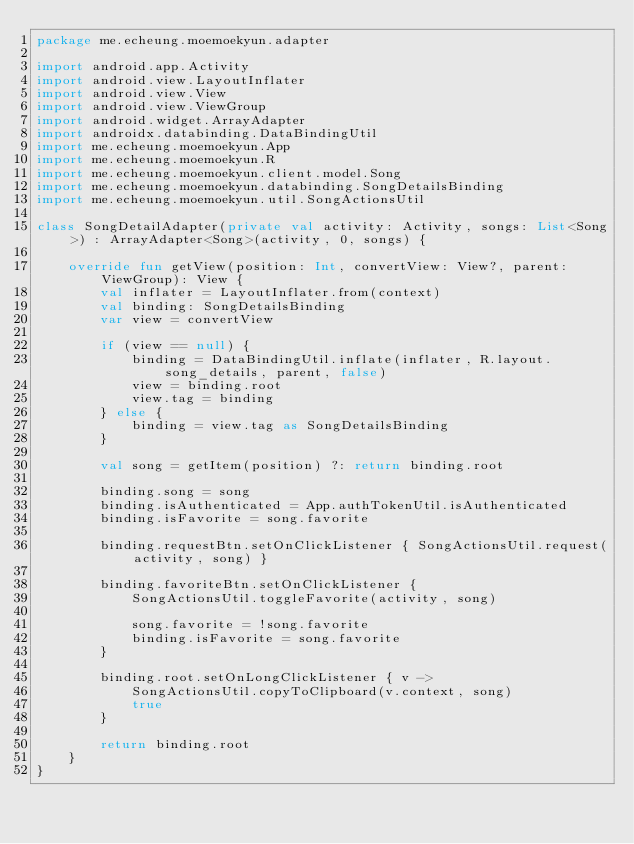<code> <loc_0><loc_0><loc_500><loc_500><_Kotlin_>package me.echeung.moemoekyun.adapter

import android.app.Activity
import android.view.LayoutInflater
import android.view.View
import android.view.ViewGroup
import android.widget.ArrayAdapter
import androidx.databinding.DataBindingUtil
import me.echeung.moemoekyun.App
import me.echeung.moemoekyun.R
import me.echeung.moemoekyun.client.model.Song
import me.echeung.moemoekyun.databinding.SongDetailsBinding
import me.echeung.moemoekyun.util.SongActionsUtil

class SongDetailAdapter(private val activity: Activity, songs: List<Song>) : ArrayAdapter<Song>(activity, 0, songs) {

    override fun getView(position: Int, convertView: View?, parent: ViewGroup): View {
        val inflater = LayoutInflater.from(context)
        val binding: SongDetailsBinding
        var view = convertView

        if (view == null) {
            binding = DataBindingUtil.inflate(inflater, R.layout.song_details, parent, false)
            view = binding.root
            view.tag = binding
        } else {
            binding = view.tag as SongDetailsBinding
        }

        val song = getItem(position) ?: return binding.root

        binding.song = song
        binding.isAuthenticated = App.authTokenUtil.isAuthenticated
        binding.isFavorite = song.favorite

        binding.requestBtn.setOnClickListener { SongActionsUtil.request(activity, song) }

        binding.favoriteBtn.setOnClickListener {
            SongActionsUtil.toggleFavorite(activity, song)

            song.favorite = !song.favorite
            binding.isFavorite = song.favorite
        }

        binding.root.setOnLongClickListener { v ->
            SongActionsUtil.copyToClipboard(v.context, song)
            true
        }

        return binding.root
    }
}
</code> 